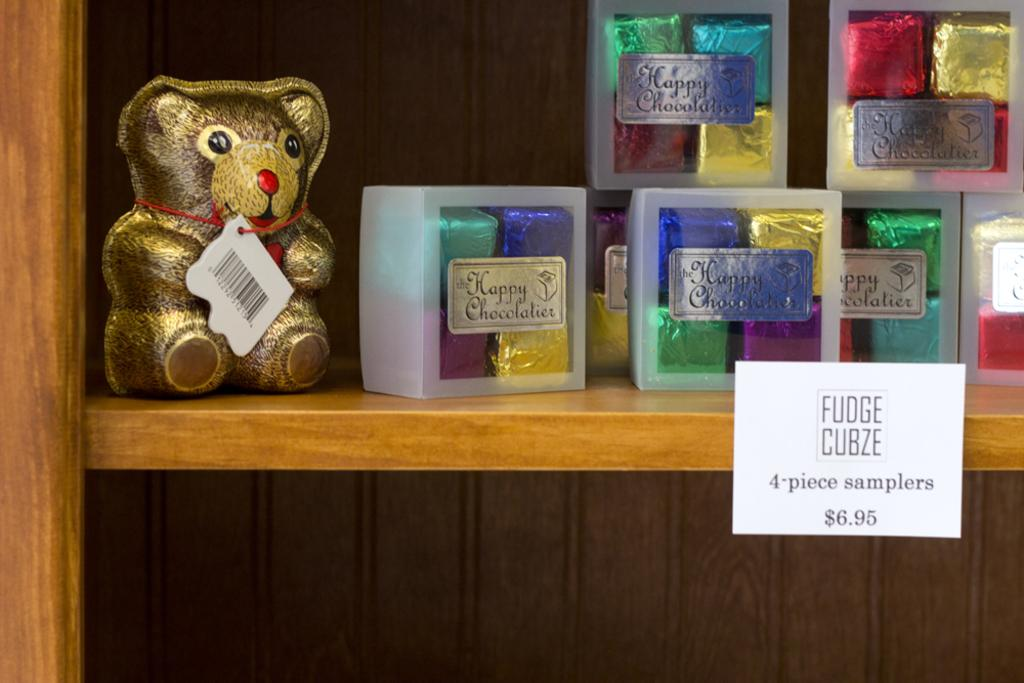<image>
Share a concise interpretation of the image provided. a display of Fudge Cubze 4 piece sampler for $6.95 